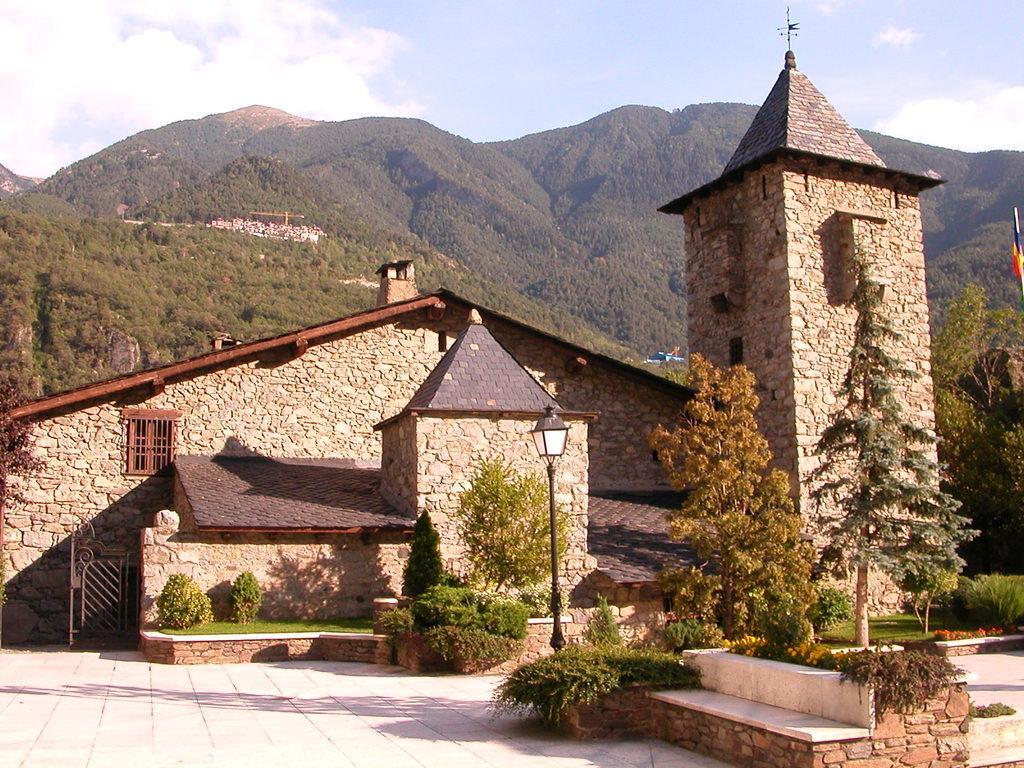Please provide a concise description of this image. This image consists of a house which is in the center. In the front there are trees, plants, and there is a bench on the wall which is white in colour and there is a light pole. In the background there are mountains and the sky is cloudy. 